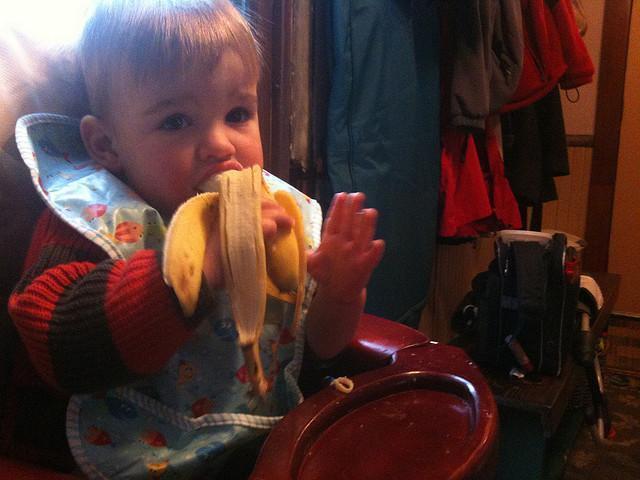How many people are there?
Give a very brief answer. 2. How many handbags are there?
Give a very brief answer. 2. 